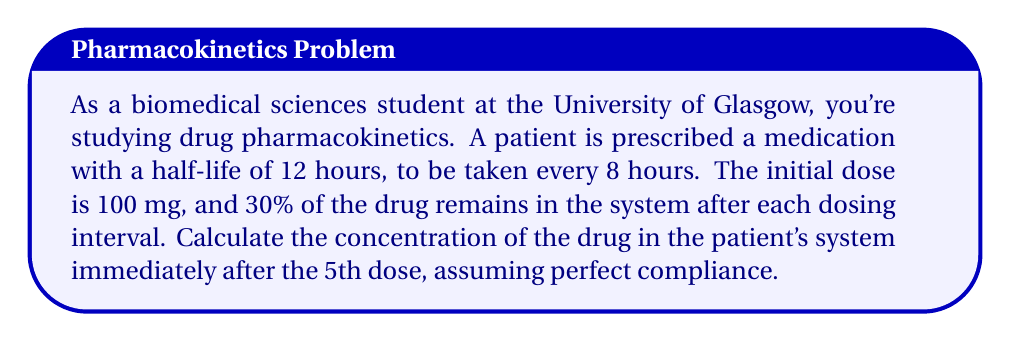Give your solution to this math problem. To solve this problem, we'll use a geometric sequence approach:

1) First, let's define our variables:
   $a$ = initial dose = 100 mg
   $r$ = retention rate = 0.30 (30% remains after each interval)
   $n$ = number of doses = 5

2) The amount of drug remaining from each dose just before the next dose is given:
   1st dose: $a$
   2nd dose: $ar + a$
   3rd dose: $ar^2 + ar + a$
   4th dose: $ar^3 + ar^2 + ar + a$
   5th dose: $ar^4 + ar^3 + ar^2 + ar + a$

3) This forms a geometric series with $n$ terms, where the first term is $ar^{n-1}$ and the common ratio is $\frac{1}{r}$. The sum of this series is given by the formula:

   $$S_n = \frac{a(1-r^n)}{1-r}$$

4) Substituting our values:

   $$S_5 = \frac{100(1-0.30^5)}{1-0.30}$$

5) Calculate:
   $$S_5 = \frac{100(1-0.00243)}{0.70} = \frac{99.757}{0.70} = 142.51 \text{ mg}$$

Therefore, the concentration of the drug in the patient's system immediately after the 5th dose is approximately 142.51 mg.
Answer: 142.51 mg 